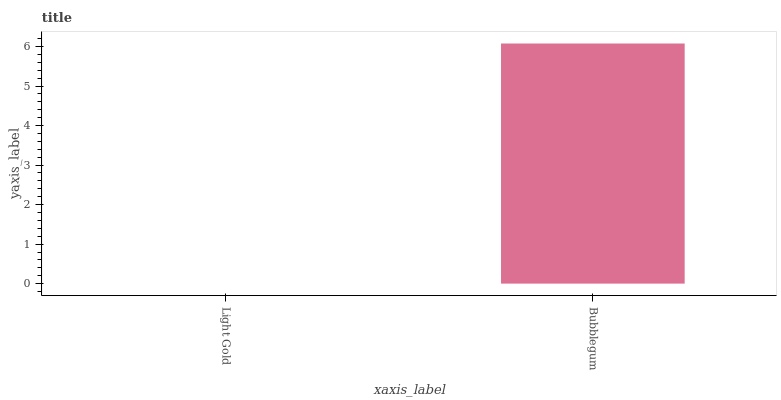Is Light Gold the minimum?
Answer yes or no. Yes. Is Bubblegum the maximum?
Answer yes or no. Yes. Is Bubblegum the minimum?
Answer yes or no. No. Is Bubblegum greater than Light Gold?
Answer yes or no. Yes. Is Light Gold less than Bubblegum?
Answer yes or no. Yes. Is Light Gold greater than Bubblegum?
Answer yes or no. No. Is Bubblegum less than Light Gold?
Answer yes or no. No. Is Bubblegum the high median?
Answer yes or no. Yes. Is Light Gold the low median?
Answer yes or no. Yes. Is Light Gold the high median?
Answer yes or no. No. Is Bubblegum the low median?
Answer yes or no. No. 